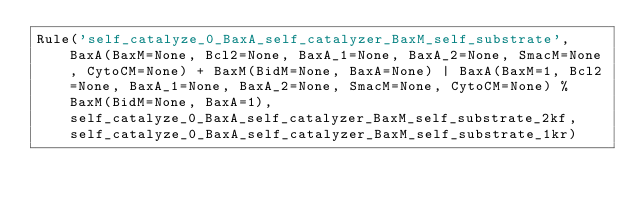<code> <loc_0><loc_0><loc_500><loc_500><_Python_>Rule('self_catalyze_0_BaxA_self_catalyzer_BaxM_self_substrate', BaxA(BaxM=None, Bcl2=None, BaxA_1=None, BaxA_2=None, SmacM=None, CytoCM=None) + BaxM(BidM=None, BaxA=None) | BaxA(BaxM=1, Bcl2=None, BaxA_1=None, BaxA_2=None, SmacM=None, CytoCM=None) % BaxM(BidM=None, BaxA=1), self_catalyze_0_BaxA_self_catalyzer_BaxM_self_substrate_2kf, self_catalyze_0_BaxA_self_catalyzer_BaxM_self_substrate_1kr)</code> 